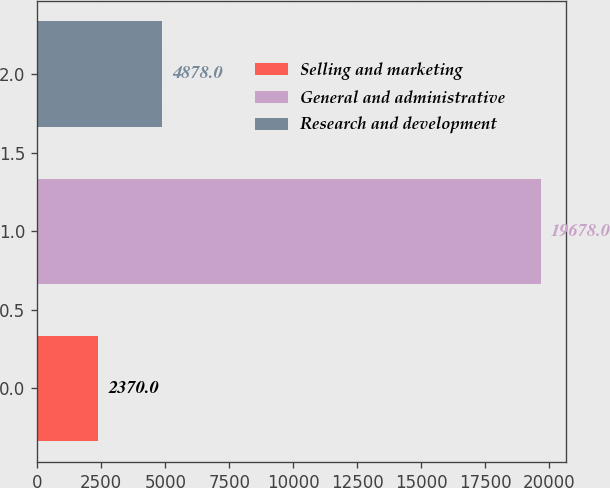<chart> <loc_0><loc_0><loc_500><loc_500><bar_chart><fcel>Selling and marketing<fcel>General and administrative<fcel>Research and development<nl><fcel>2370<fcel>19678<fcel>4878<nl></chart> 